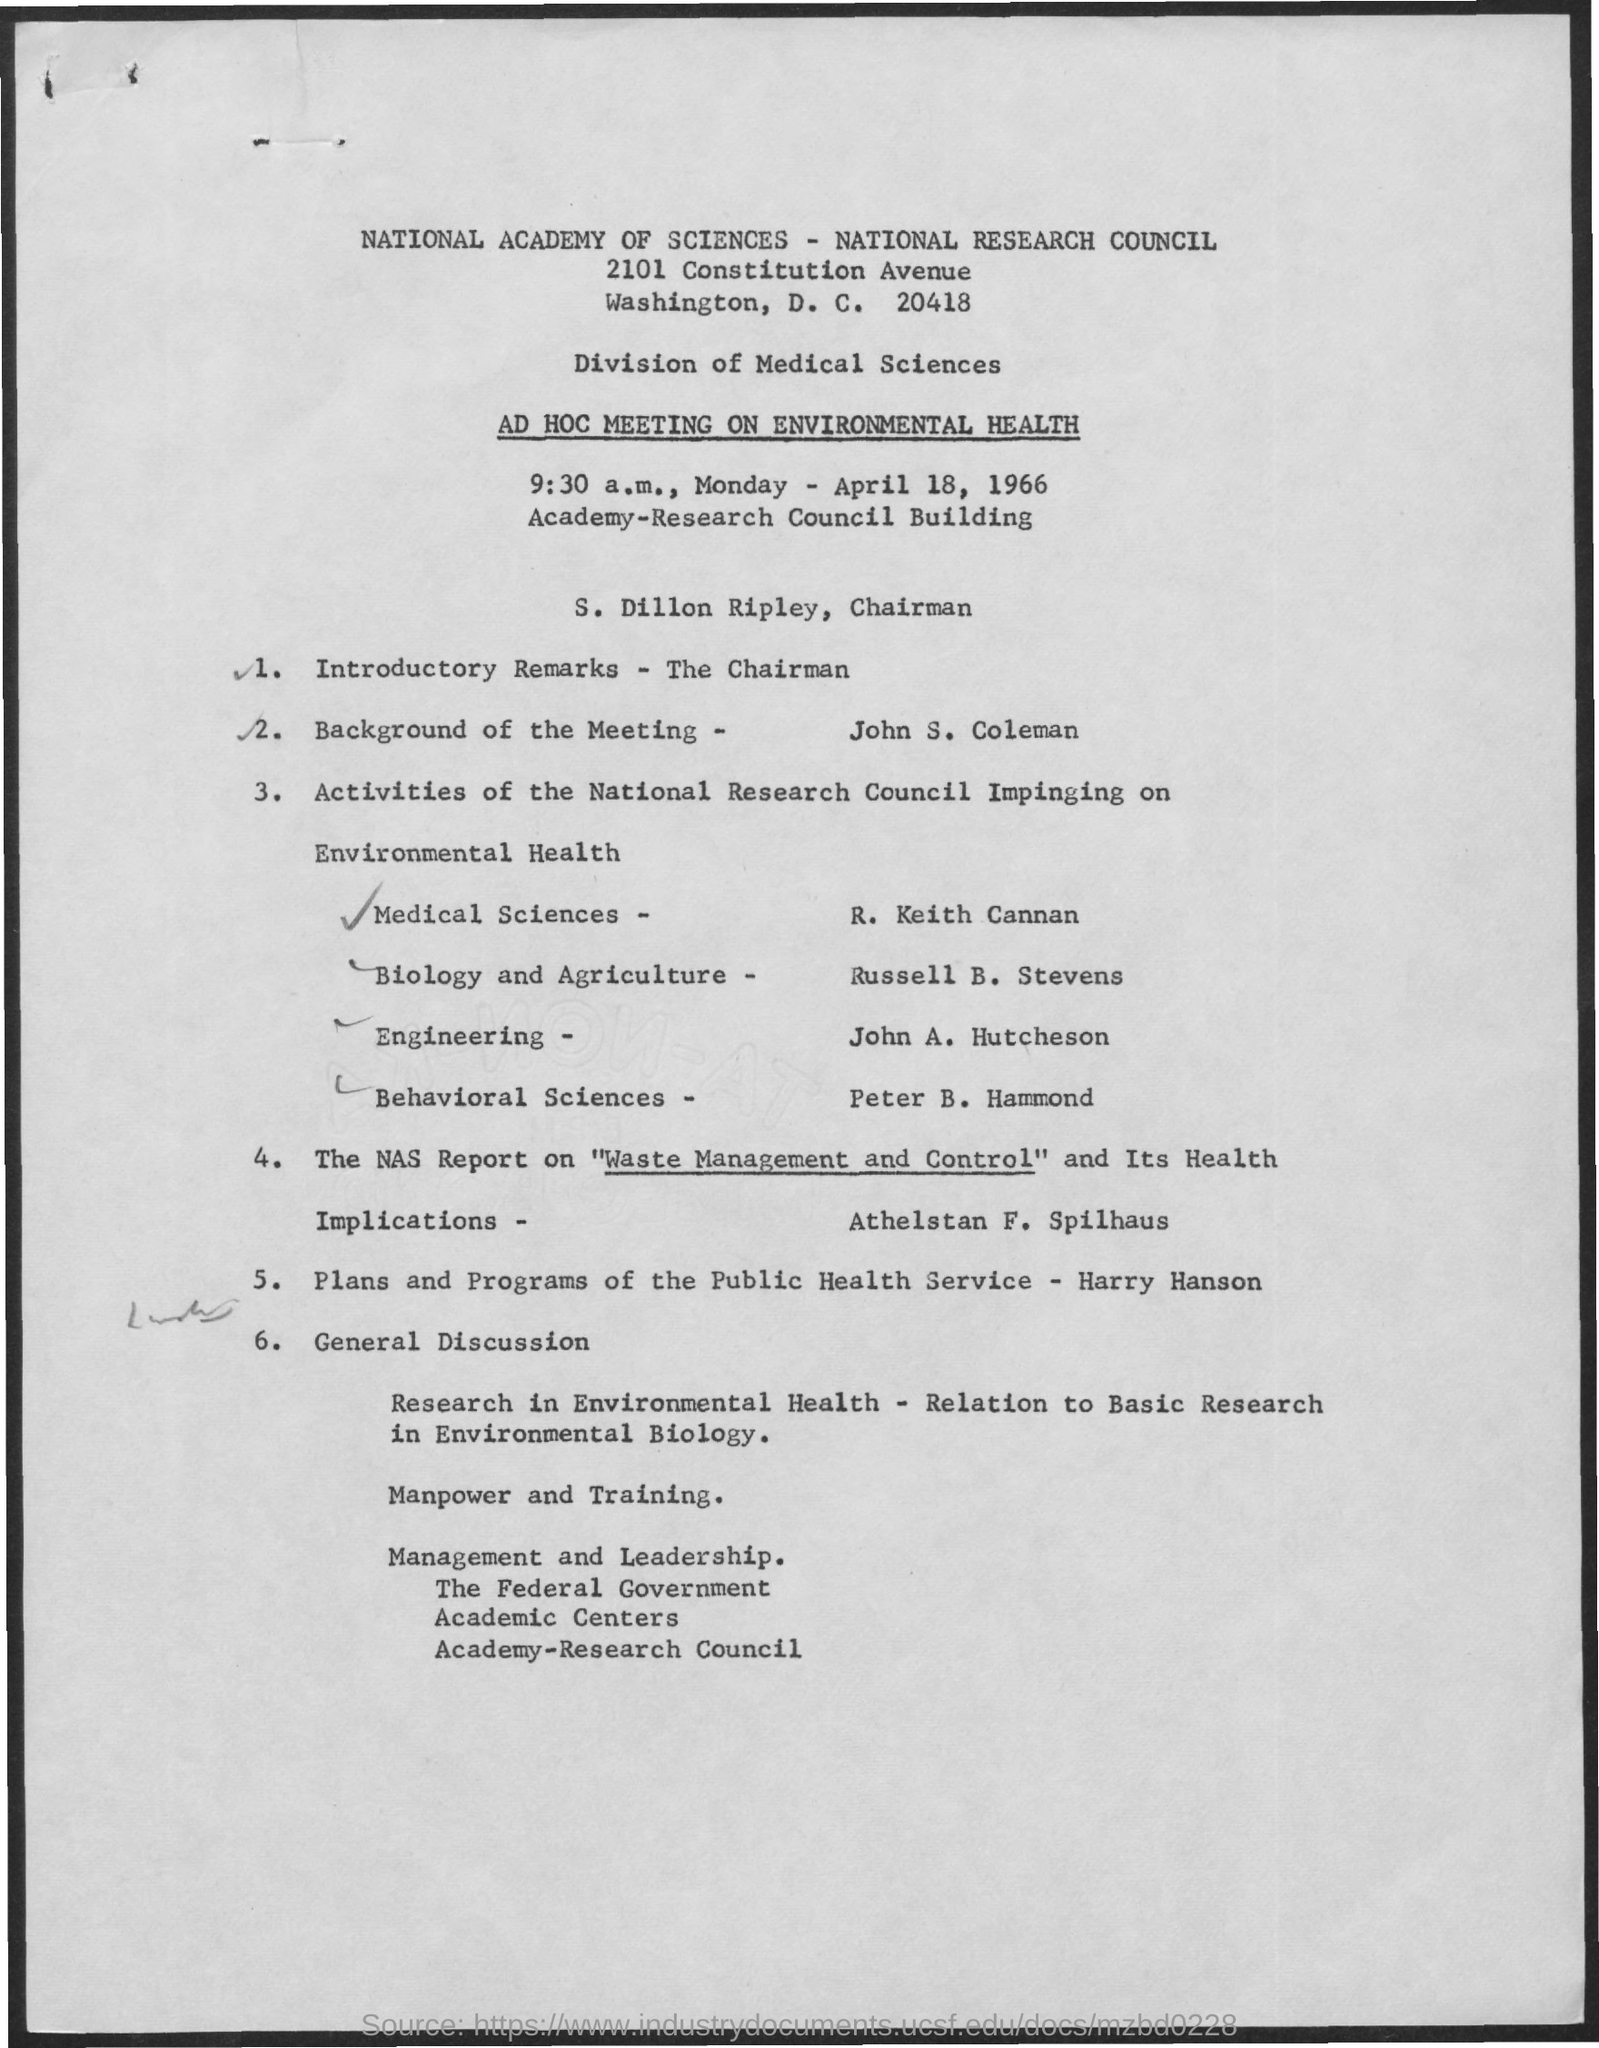Outline some significant characteristics in this image. Dillon Ripley is the Chairman. 